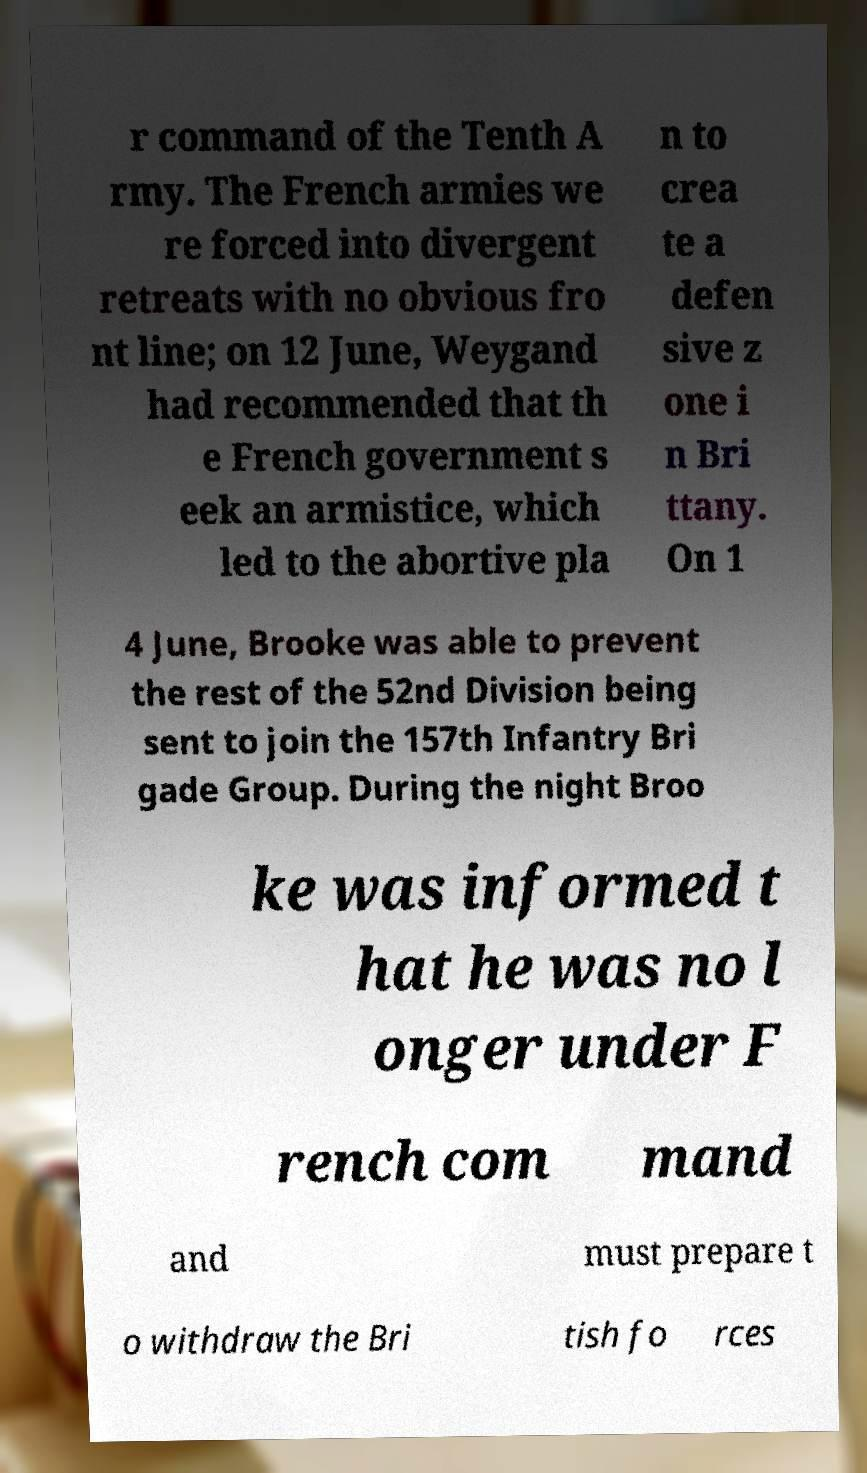What messages or text are displayed in this image? I need them in a readable, typed format. r command of the Tenth A rmy. The French armies we re forced into divergent retreats with no obvious fro nt line; on 12 June, Weygand had recommended that th e French government s eek an armistice, which led to the abortive pla n to crea te a defen sive z one i n Bri ttany. On 1 4 June, Brooke was able to prevent the rest of the 52nd Division being sent to join the 157th Infantry Bri gade Group. During the night Broo ke was informed t hat he was no l onger under F rench com mand and must prepare t o withdraw the Bri tish fo rces 